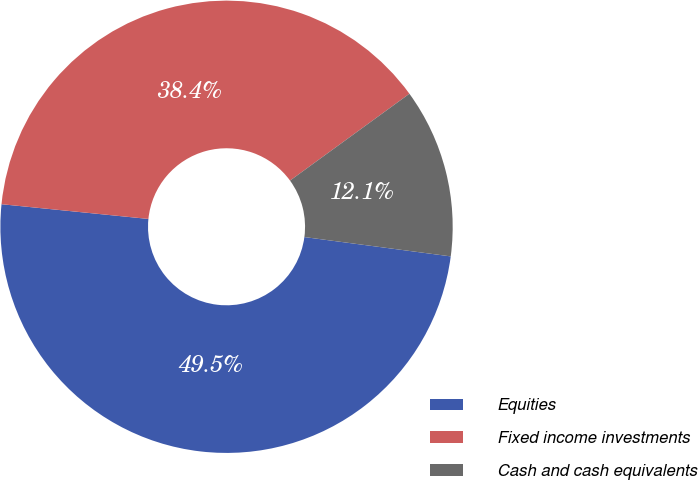Convert chart. <chart><loc_0><loc_0><loc_500><loc_500><pie_chart><fcel>Equities<fcel>Fixed income investments<fcel>Cash and cash equivalents<nl><fcel>49.5%<fcel>38.4%<fcel>12.1%<nl></chart> 